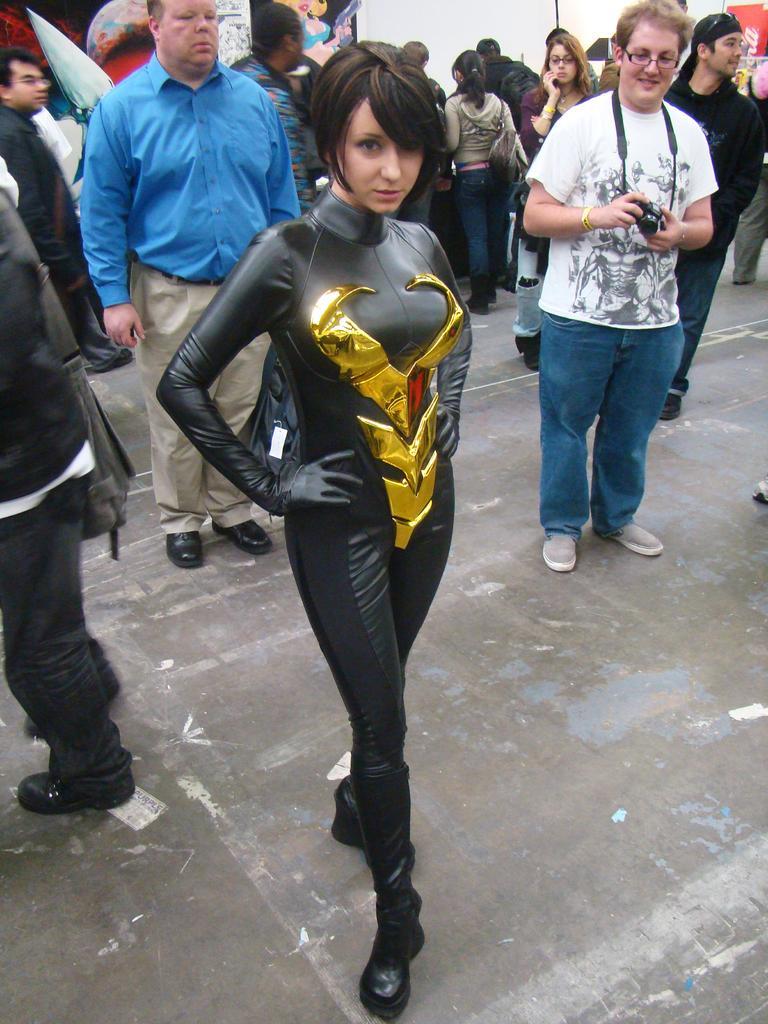Can you describe this image briefly? In this image I can see group of people standing, the person in front wearing black and gold color dress. Background I can see the other person holding the camera and I can see the wall in white color. 